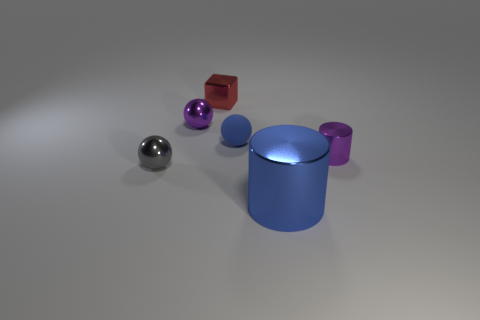Add 3 tiny cyan cylinders. How many objects exist? 9 Subtract all cylinders. How many objects are left? 4 Add 2 purple cylinders. How many purple cylinders exist? 3 Subtract 1 red blocks. How many objects are left? 5 Subtract all large metallic cylinders. Subtract all cubes. How many objects are left? 4 Add 6 big blue metal things. How many big blue metal things are left? 7 